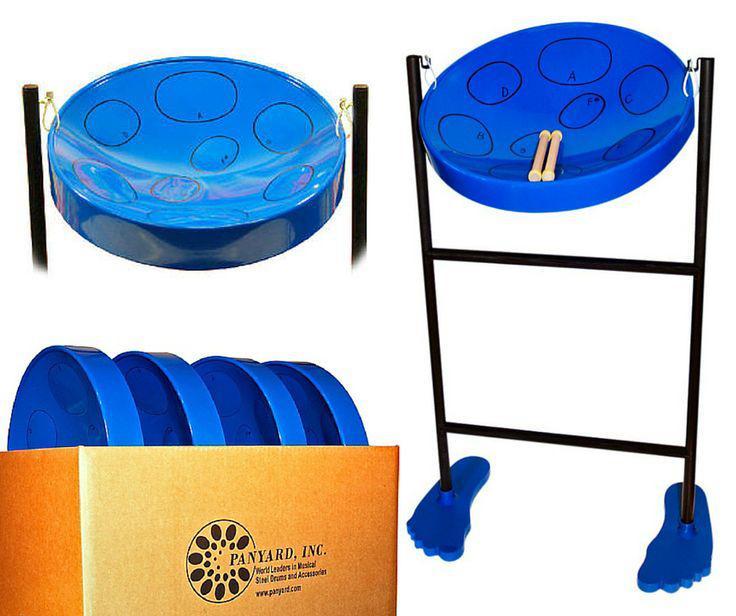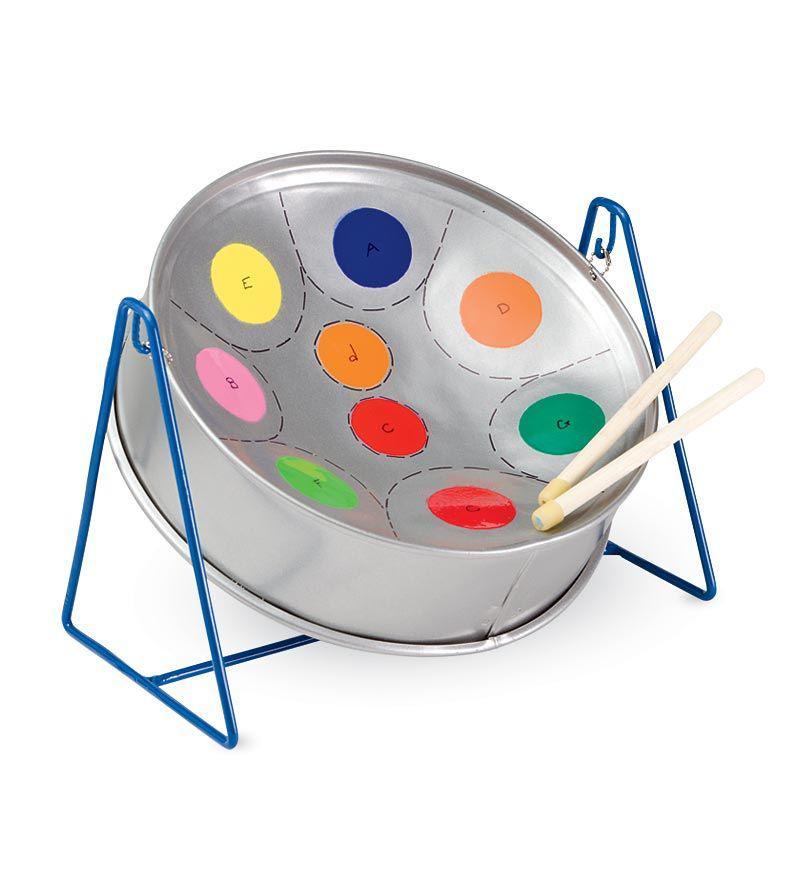The first image is the image on the left, the second image is the image on the right. Evaluate the accuracy of this statement regarding the images: "All the drums are blue.". Is it true? Answer yes or no. No. 